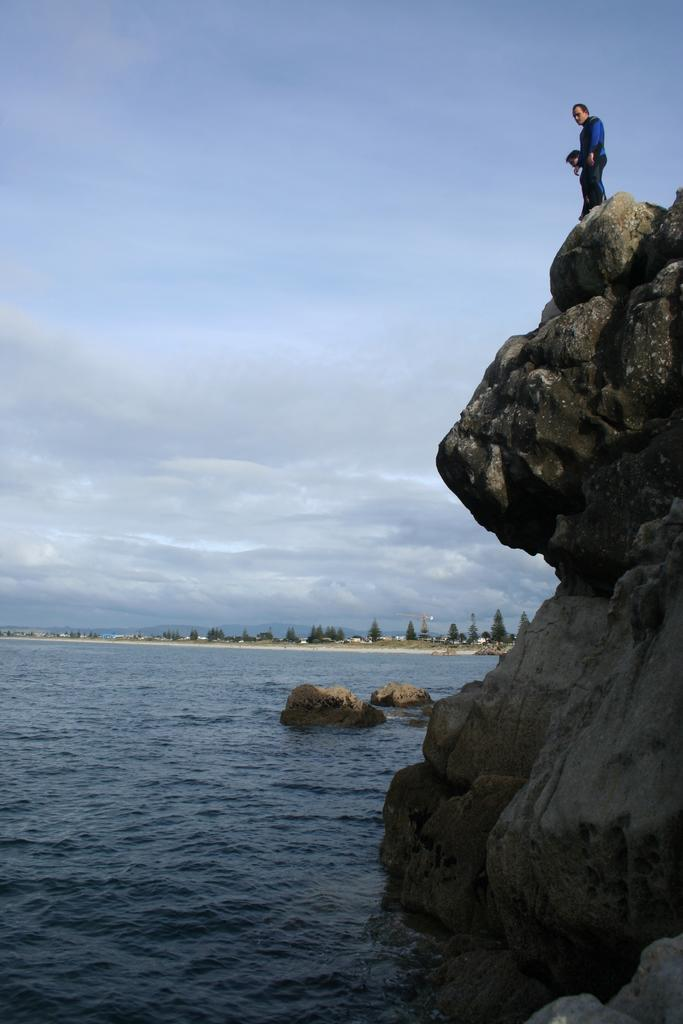What is happening in the foreground of the image? There are people on a hill in the foreground of the image. What can be seen in the background of the image? There are trees, houses, water, and the sky visible in the background of the image. How many men are present in the image? The provided facts do not mention the number of men or any specific individuals in the image. What is the son doing in the image? There is no mention of a son or any specific individuals in the image. 